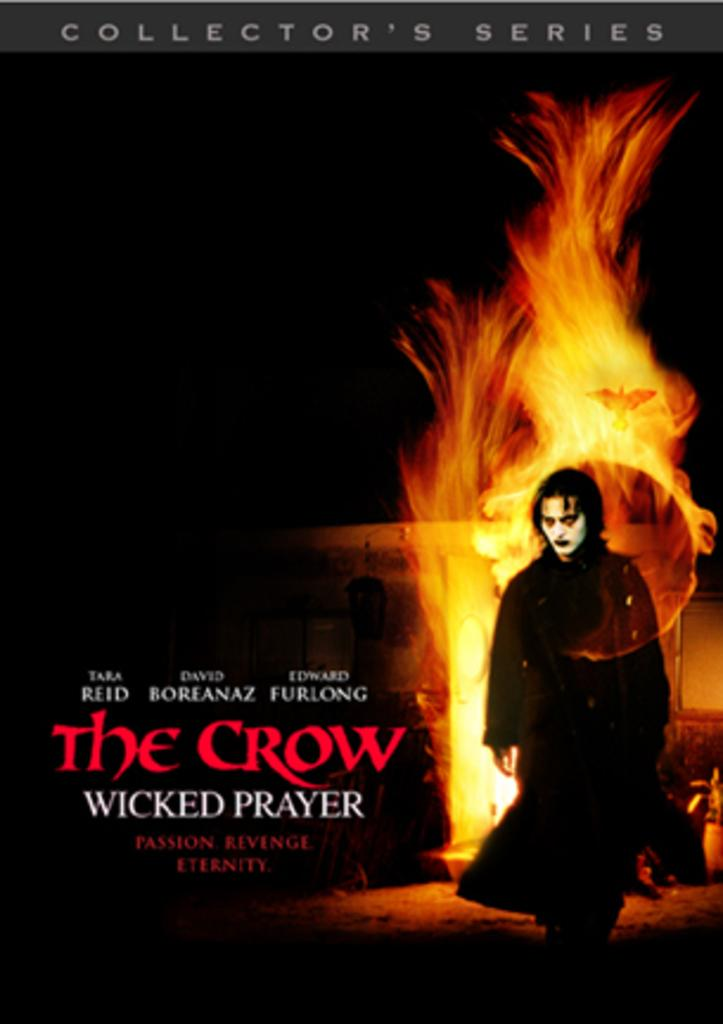Provide a one-sentence caption for the provided image. A poster advertising the movie The Crow, Wicked Prayer. 